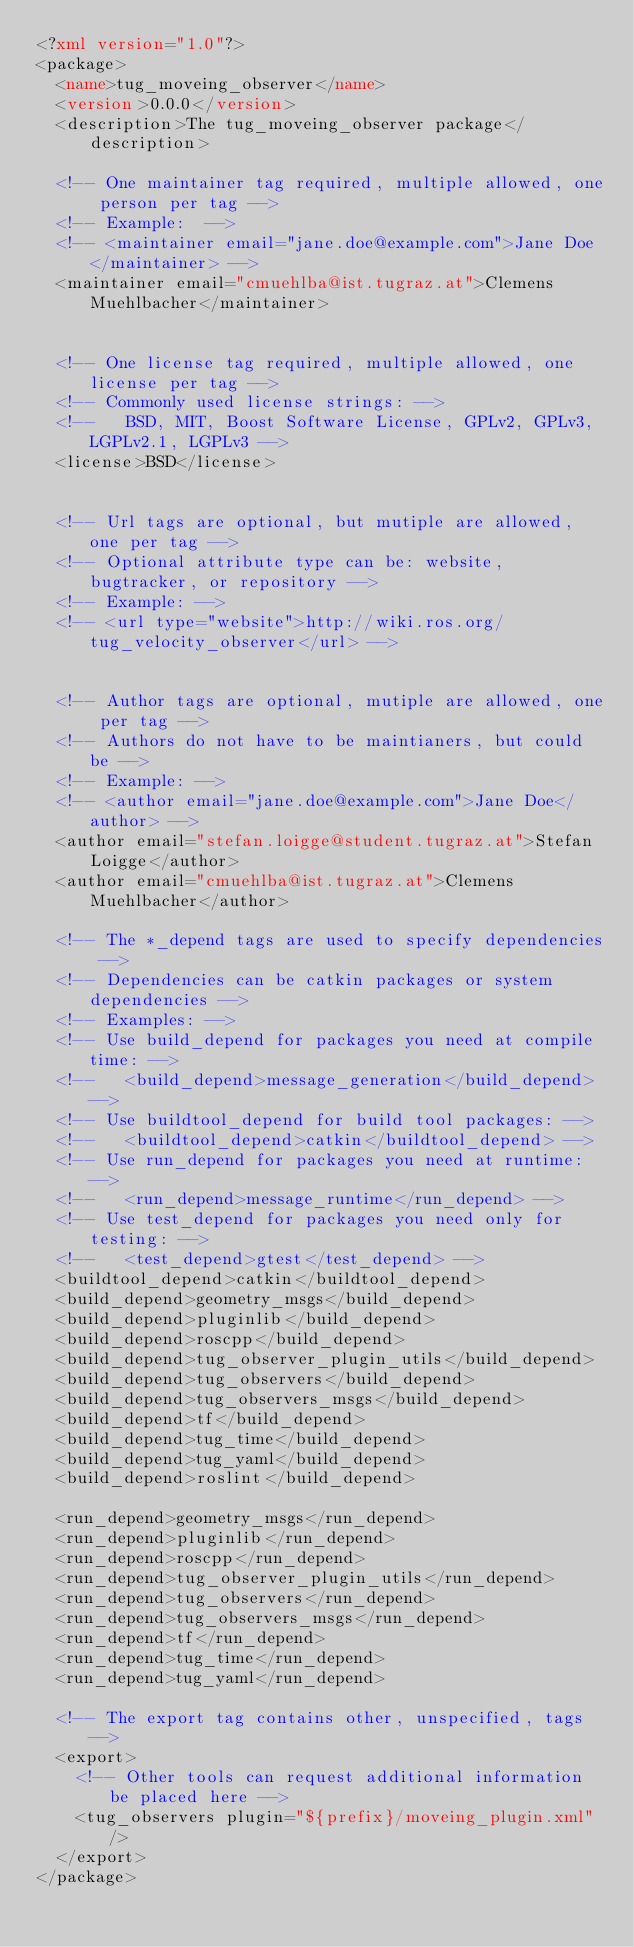<code> <loc_0><loc_0><loc_500><loc_500><_XML_><?xml version="1.0"?>
<package>
  <name>tug_moveing_observer</name>
  <version>0.0.0</version>
  <description>The tug_moveing_observer package</description>

  <!-- One maintainer tag required, multiple allowed, one person per tag --> 
  <!-- Example:  -->
  <!-- <maintainer email="jane.doe@example.com">Jane Doe</maintainer> -->
  <maintainer email="cmuehlba@ist.tugraz.at">Clemens Muehlbacher</maintainer>


  <!-- One license tag required, multiple allowed, one license per tag -->
  <!-- Commonly used license strings: -->
  <!--   BSD, MIT, Boost Software License, GPLv2, GPLv3, LGPLv2.1, LGPLv3 -->
  <license>BSD</license>


  <!-- Url tags are optional, but mutiple are allowed, one per tag -->
  <!-- Optional attribute type can be: website, bugtracker, or repository -->
  <!-- Example: -->
  <!-- <url type="website">http://wiki.ros.org/tug_velocity_observer</url> -->


  <!-- Author tags are optional, mutiple are allowed, one per tag -->
  <!-- Authors do not have to be maintianers, but could be -->
  <!-- Example: -->
  <!-- <author email="jane.doe@example.com">Jane Doe</author> -->
  <author email="stefan.loigge@student.tugraz.at">Stefan Loigge</author>
  <author email="cmuehlba@ist.tugraz.at">Clemens Muehlbacher</author>

  <!-- The *_depend tags are used to specify dependencies -->
  <!-- Dependencies can be catkin packages or system dependencies -->
  <!-- Examples: -->
  <!-- Use build_depend for packages you need at compile time: -->
  <!--   <build_depend>message_generation</build_depend> -->
  <!-- Use buildtool_depend for build tool packages: -->
  <!--   <buildtool_depend>catkin</buildtool_depend> -->
  <!-- Use run_depend for packages you need at runtime: -->
  <!--   <run_depend>message_runtime</run_depend> -->
  <!-- Use test_depend for packages you need only for testing: -->
  <!--   <test_depend>gtest</test_depend> -->
  <buildtool_depend>catkin</buildtool_depend>
  <build_depend>geometry_msgs</build_depend>
  <build_depend>pluginlib</build_depend>
  <build_depend>roscpp</build_depend>
  <build_depend>tug_observer_plugin_utils</build_depend>
  <build_depend>tug_observers</build_depend>
  <build_depend>tug_observers_msgs</build_depend>
  <build_depend>tf</build_depend>
  <build_depend>tug_time</build_depend>
  <build_depend>tug_yaml</build_depend>
  <build_depend>roslint</build_depend>

  <run_depend>geometry_msgs</run_depend>
  <run_depend>pluginlib</run_depend>
  <run_depend>roscpp</run_depend>
  <run_depend>tug_observer_plugin_utils</run_depend>
  <run_depend>tug_observers</run_depend>
  <run_depend>tug_observers_msgs</run_depend>
  <run_depend>tf</run_depend>
  <run_depend>tug_time</run_depend>
  <run_depend>tug_yaml</run_depend>

  <!-- The export tag contains other, unspecified, tags -->
  <export>
    <!-- Other tools can request additional information be placed here -->
    <tug_observers plugin="${prefix}/moveing_plugin.xml" />
  </export>
</package>
</code> 